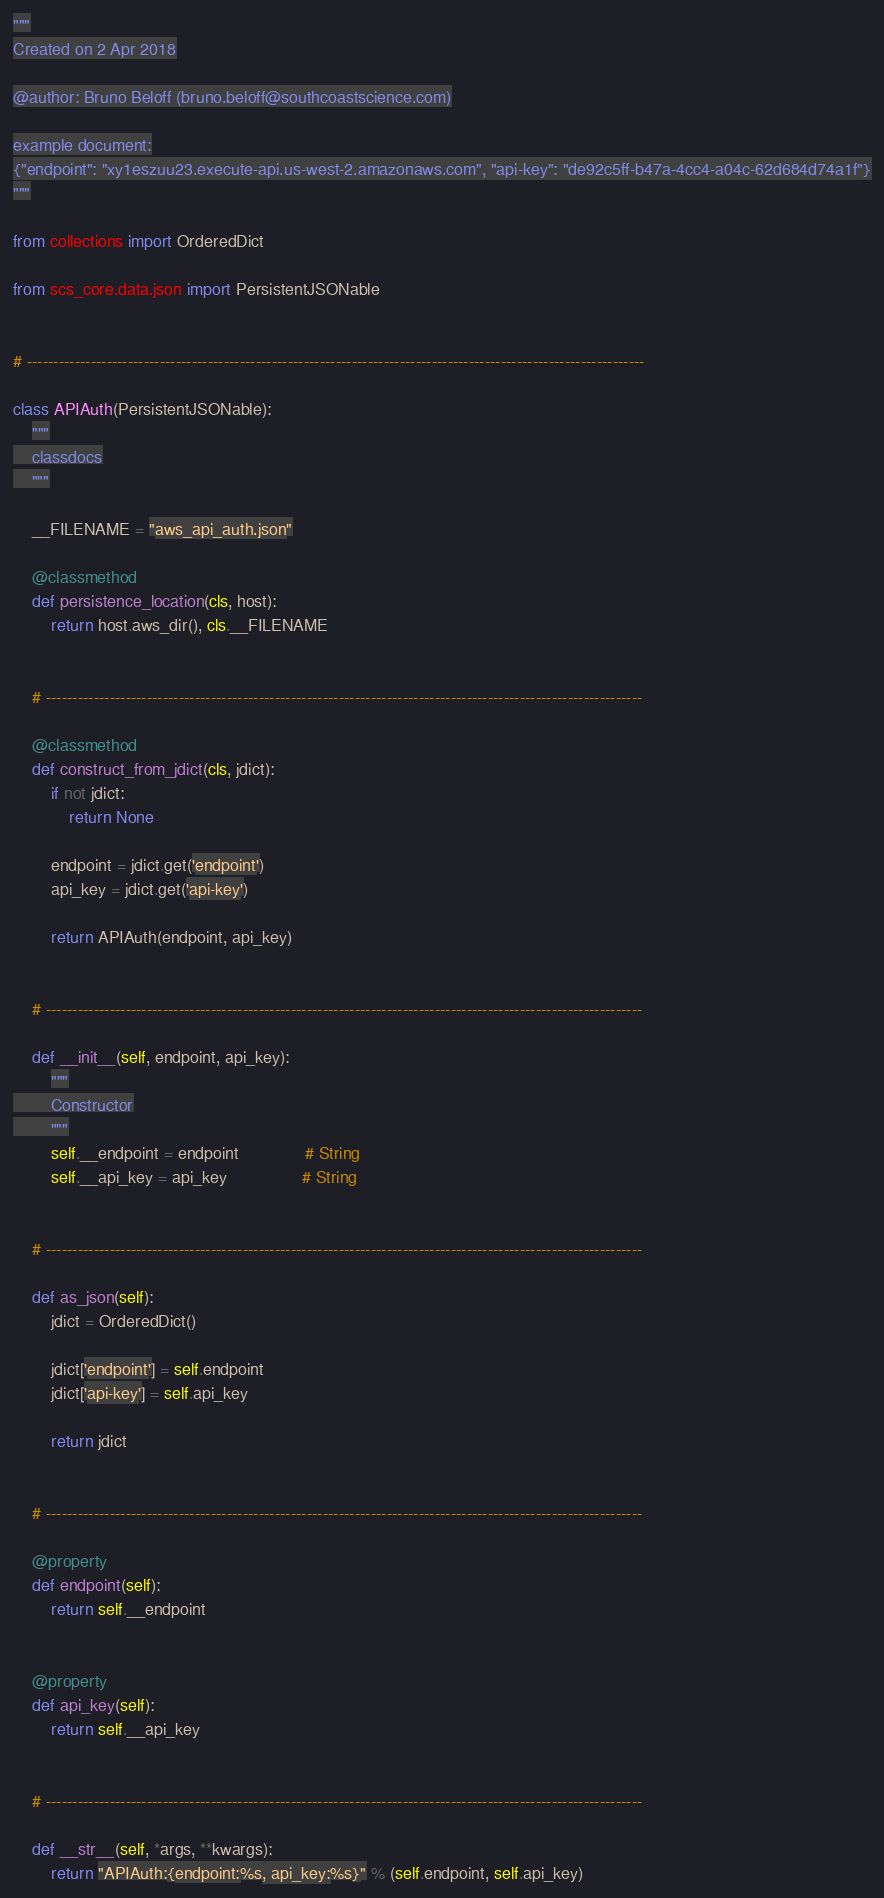Convert code to text. <code><loc_0><loc_0><loc_500><loc_500><_Python_>"""
Created on 2 Apr 2018

@author: Bruno Beloff (bruno.beloff@southcoastscience.com)

example document:
{"endpoint": "xy1eszuu23.execute-api.us-west-2.amazonaws.com", "api-key": "de92c5ff-b47a-4cc4-a04c-62d684d74a1f"}
"""

from collections import OrderedDict

from scs_core.data.json import PersistentJSONable


# --------------------------------------------------------------------------------------------------------------------

class APIAuth(PersistentJSONable):
    """
    classdocs
    """

    __FILENAME = "aws_api_auth.json"

    @classmethod
    def persistence_location(cls, host):
        return host.aws_dir(), cls.__FILENAME


    # ----------------------------------------------------------------------------------------------------------------

    @classmethod
    def construct_from_jdict(cls, jdict):
        if not jdict:
            return None

        endpoint = jdict.get('endpoint')
        api_key = jdict.get('api-key')

        return APIAuth(endpoint, api_key)


    # ----------------------------------------------------------------------------------------------------------------

    def __init__(self, endpoint, api_key):
        """
        Constructor
        """
        self.__endpoint = endpoint              # String
        self.__api_key = api_key                # String


    # ----------------------------------------------------------------------------------------------------------------

    def as_json(self):
        jdict = OrderedDict()

        jdict['endpoint'] = self.endpoint
        jdict['api-key'] = self.api_key

        return jdict


    # ----------------------------------------------------------------------------------------------------------------

    @property
    def endpoint(self):
        return self.__endpoint


    @property
    def api_key(self):
        return self.__api_key


    # ----------------------------------------------------------------------------------------------------------------

    def __str__(self, *args, **kwargs):
        return "APIAuth:{endpoint:%s, api_key:%s}" % (self.endpoint, self.api_key)
</code> 